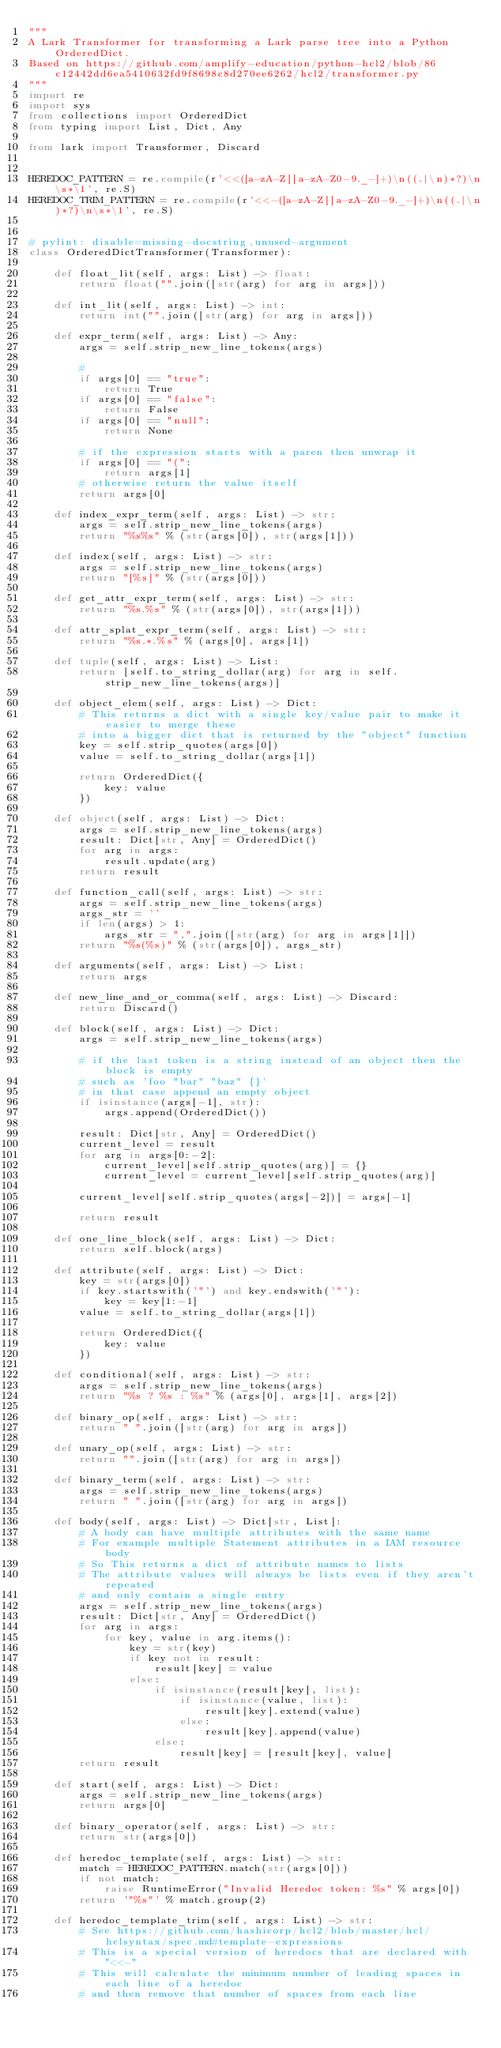<code> <loc_0><loc_0><loc_500><loc_500><_Python_>"""
A Lark Transformer for transforming a Lark parse tree into a Python OrderedDict.
Based on https://github.com/amplify-education/python-hcl2/blob/86c12442dd6ea5410632fd9f8698c8d270ee6262/hcl2/transformer.py
"""
import re
import sys
from collections import OrderedDict
from typing import List, Dict, Any

from lark import Transformer, Discard


HEREDOC_PATTERN = re.compile(r'<<([a-zA-Z][a-zA-Z0-9._-]+)\n((.|\n)*?)\n\s*\1', re.S)
HEREDOC_TRIM_PATTERN = re.compile(r'<<-([a-zA-Z][a-zA-Z0-9._-]+)\n((.|\n)*?)\n\s*\1', re.S)


# pylint: disable=missing-docstring,unused-argument
class OrderedDictTransformer(Transformer):

    def float_lit(self, args: List) -> float:
        return float("".join([str(arg) for arg in args]))

    def int_lit(self, args: List) -> int:
        return int("".join([str(arg) for arg in args]))

    def expr_term(self, args: List) -> Any:
        args = self.strip_new_line_tokens(args)

        #
        if args[0] == "true":
            return True
        if args[0] == "false":
            return False
        if args[0] == "null":
            return None

        # if the expression starts with a paren then unwrap it
        if args[0] == "(":
            return args[1]
        # otherwise return the value itself
        return args[0]

    def index_expr_term(self, args: List) -> str:
        args = self.strip_new_line_tokens(args)
        return "%s%s" % (str(args[0]), str(args[1]))

    def index(self, args: List) -> str:
        args = self.strip_new_line_tokens(args)
        return "[%s]" % (str(args[0]))

    def get_attr_expr_term(self, args: List) -> str:
        return "%s.%s" % (str(args[0]), str(args[1]))

    def attr_splat_expr_term(self, args: List) -> str:
        return "%s.*.%s" % (args[0], args[1])

    def tuple(self, args: List) -> List:
        return [self.to_string_dollar(arg) for arg in self.strip_new_line_tokens(args)]

    def object_elem(self, args: List) -> Dict:
        # This returns a dict with a single key/value pair to make it easier to merge these
        # into a bigger dict that is returned by the "object" function
        key = self.strip_quotes(args[0])
        value = self.to_string_dollar(args[1])

        return OrderedDict({
            key: value
        })

    def object(self, args: List) -> Dict:
        args = self.strip_new_line_tokens(args)
        result: Dict[str, Any] = OrderedDict()
        for arg in args:
            result.update(arg)
        return result

    def function_call(self, args: List) -> str:
        args = self.strip_new_line_tokens(args)
        args_str = ''
        if len(args) > 1:
            args_str = ",".join([str(arg) for arg in args[1]])
        return "%s(%s)" % (str(args[0]), args_str)

    def arguments(self, args: List) -> List:
        return args

    def new_line_and_or_comma(self, args: List) -> Discard:
        return Discard()

    def block(self, args: List) -> Dict:
        args = self.strip_new_line_tokens(args)

        # if the last token is a string instead of an object then the block is empty
        # such as 'foo "bar" "baz" {}'
        # in that case append an empty object
        if isinstance(args[-1], str):
            args.append(OrderedDict())

        result: Dict[str, Any] = OrderedDict()
        current_level = result
        for arg in args[0:-2]:
            current_level[self.strip_quotes(arg)] = {}
            current_level = current_level[self.strip_quotes(arg)]

        current_level[self.strip_quotes(args[-2])] = args[-1]

        return result

    def one_line_block(self, args: List) -> Dict:
        return self.block(args)

    def attribute(self, args: List) -> Dict:
        key = str(args[0])
        if key.startswith('"') and key.endswith('"'):
            key = key[1:-1]
        value = self.to_string_dollar(args[1])

        return OrderedDict({
            key: value
        })

    def conditional(self, args: List) -> str:
        args = self.strip_new_line_tokens(args)
        return "%s ? %s : %s" % (args[0], args[1], args[2])

    def binary_op(self, args: List) -> str:
        return " ".join([str(arg) for arg in args])

    def unary_op(self, args: List) -> str:
        return "".join([str(arg) for arg in args])

    def binary_term(self, args: List) -> str:
        args = self.strip_new_line_tokens(args)
        return " ".join([str(arg) for arg in args])

    def body(self, args: List) -> Dict[str, List]:
        # A body can have multiple attributes with the same name
        # For example multiple Statement attributes in a IAM resource body
        # So This returns a dict of attribute names to lists
        # The attribute values will always be lists even if they aren't repeated
        # and only contain a single entry
        args = self.strip_new_line_tokens(args)
        result: Dict[str, Any] = OrderedDict()
        for arg in args:
            for key, value in arg.items():
                key = str(key)
                if key not in result:
                    result[key] = value
                else:
                    if isinstance(result[key], list):
                        if isinstance(value, list):
                            result[key].extend(value)
                        else:
                            result[key].append(value)
                    else:
                        result[key] = [result[key], value]
        return result

    def start(self, args: List) -> Dict:
        args = self.strip_new_line_tokens(args)
        return args[0]

    def binary_operator(self, args: List) -> str:
        return str(args[0])

    def heredoc_template(self, args: List) -> str:
        match = HEREDOC_PATTERN.match(str(args[0]))
        if not match:
            raise RuntimeError("Invalid Heredoc token: %s" % args[0])
        return '"%s"' % match.group(2)

    def heredoc_template_trim(self, args: List) -> str:
        # See https://github.com/hashicorp/hcl2/blob/master/hcl/hclsyntax/spec.md#template-expressions
        # This is a special version of heredocs that are declared with "<<-"
        # This will calculate the minimum number of leading spaces in each line of a heredoc
        # and then remove that number of spaces from each line</code> 